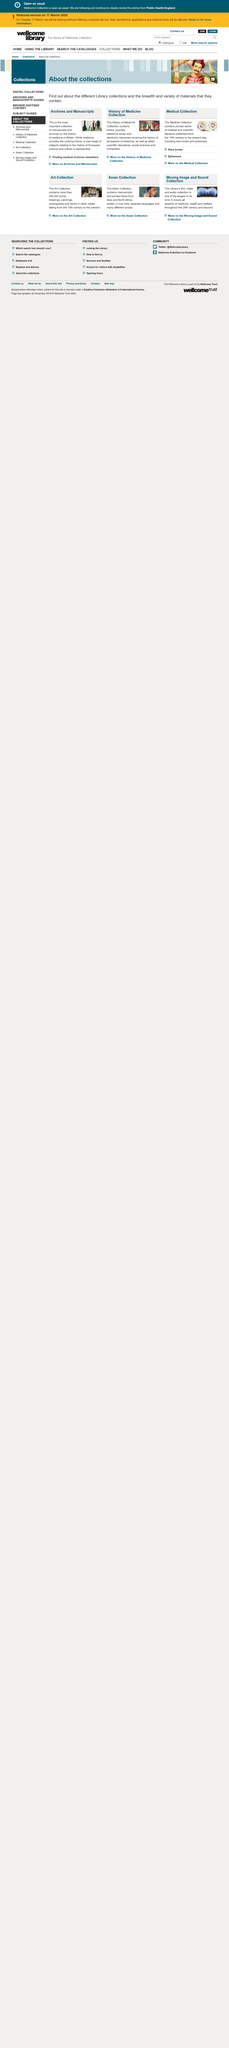Identify some key points in this picture. The History of Medicine collection contains electronic resources. The History of Medicine collection covers a wide range of topics beyond just medical history, including scientific disciplines, social sciences, and humanities. There are two pictures in the screenshot. 